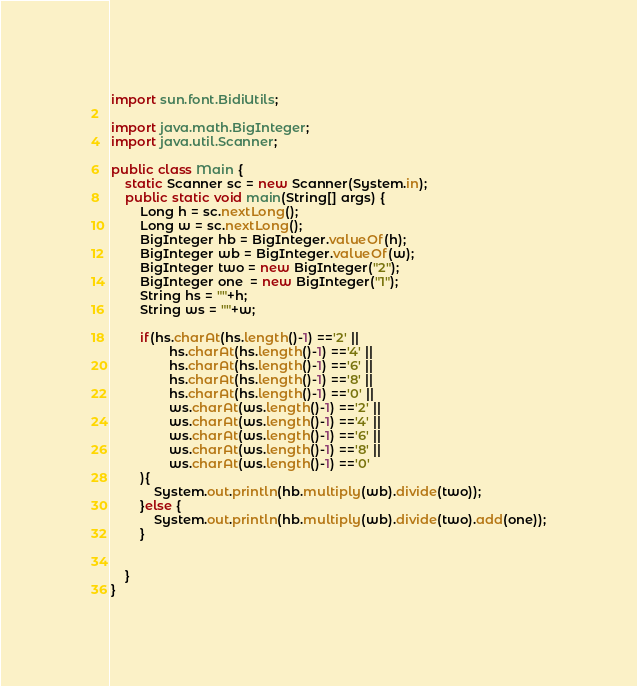<code> <loc_0><loc_0><loc_500><loc_500><_Java_>import sun.font.BidiUtils;

import java.math.BigInteger;
import java.util.Scanner;

public class Main {
    static Scanner sc = new Scanner(System.in);
    public static void main(String[] args) {
        Long h = sc.nextLong();
        Long w = sc.nextLong();
        BigInteger hb = BigInteger.valueOf(h);
        BigInteger wb = BigInteger.valueOf(w);
        BigInteger two = new BigInteger("2");
        BigInteger one  = new BigInteger("1");
        String hs = ""+h;
        String ws = ""+w;

        if(hs.charAt(hs.length()-1) =='2' ||
                hs.charAt(hs.length()-1) =='4' ||
                hs.charAt(hs.length()-1) =='6' ||
                hs.charAt(hs.length()-1) =='8' ||
                hs.charAt(hs.length()-1) =='0' ||
                ws.charAt(ws.length()-1) =='2' ||
                ws.charAt(ws.length()-1) =='4' ||
                ws.charAt(ws.length()-1) =='6' ||
                ws.charAt(ws.length()-1) =='8' ||
                ws.charAt(ws.length()-1) =='0'
        ){
            System.out.println(hb.multiply(wb).divide(two));
        }else {
            System.out.println(hb.multiply(wb).divide(two).add(one));
        }


    }
}</code> 